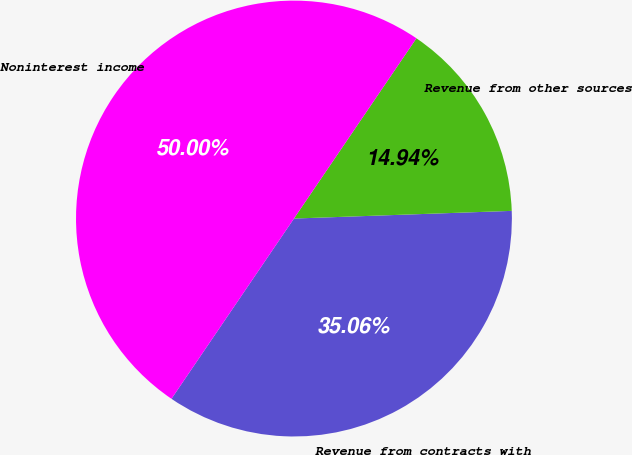Convert chart to OTSL. <chart><loc_0><loc_0><loc_500><loc_500><pie_chart><fcel>Revenue from contracts with<fcel>Revenue from other sources<fcel>Noninterest income<nl><fcel>35.06%<fcel>14.94%<fcel>50.0%<nl></chart> 